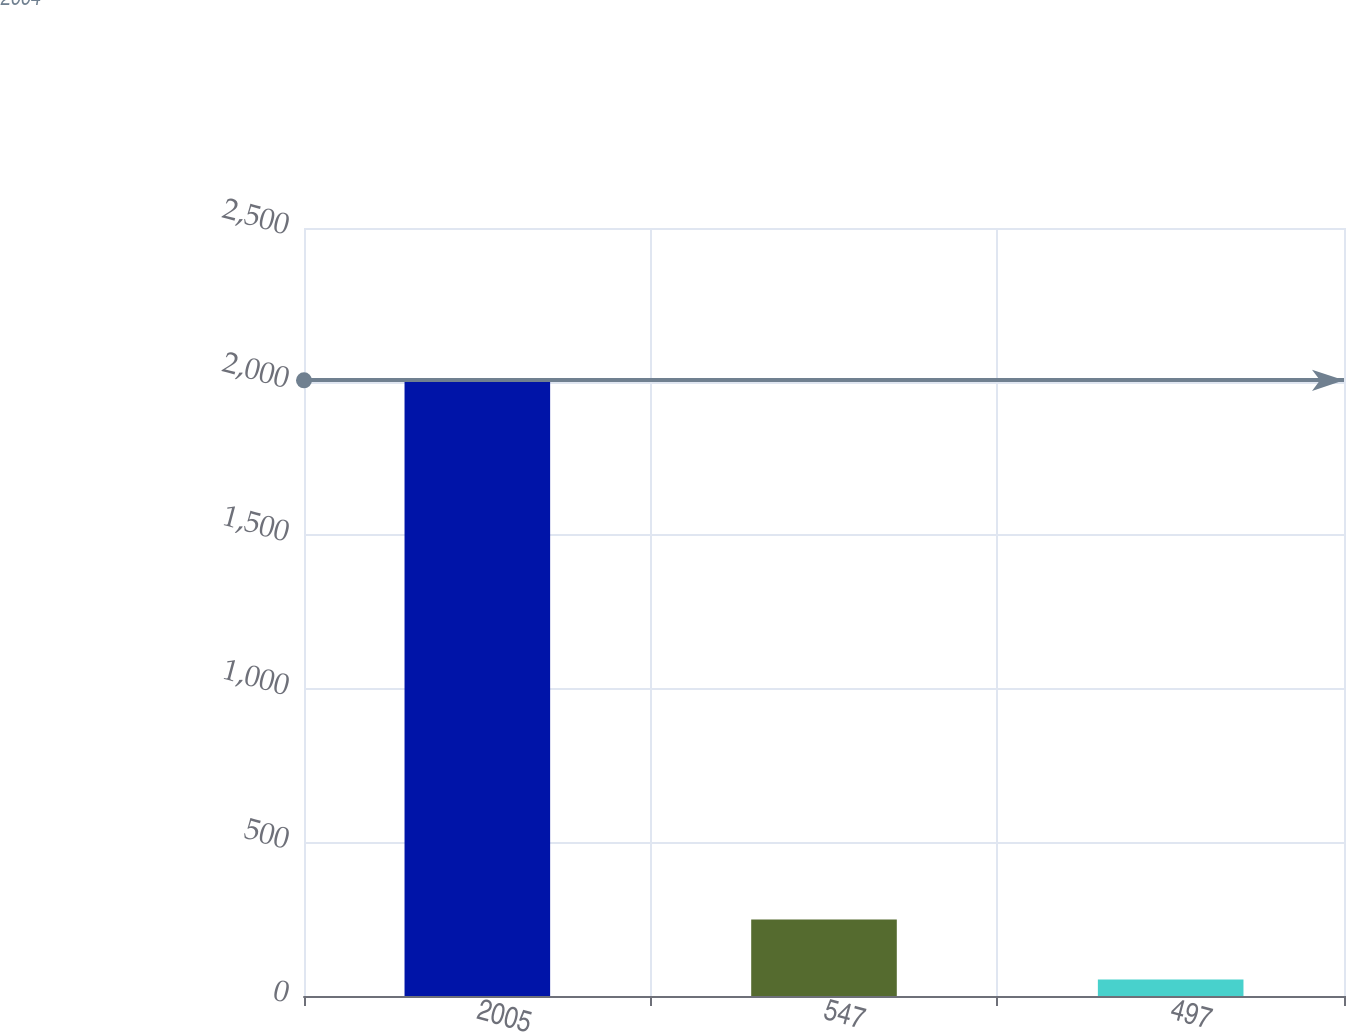Convert chart to OTSL. <chart><loc_0><loc_0><loc_500><loc_500><bar_chart><fcel>2005<fcel>547<fcel>497<nl><fcel>2004<fcel>248.64<fcel>53.6<nl></chart> 